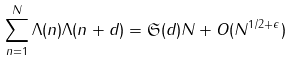Convert formula to latex. <formula><loc_0><loc_0><loc_500><loc_500>\sum _ { n = 1 } ^ { N } \Lambda ( n ) \Lambda ( n + d ) = { \mathfrak S } ( d ) N + O ( N ^ { 1 / 2 + \epsilon } )</formula> 